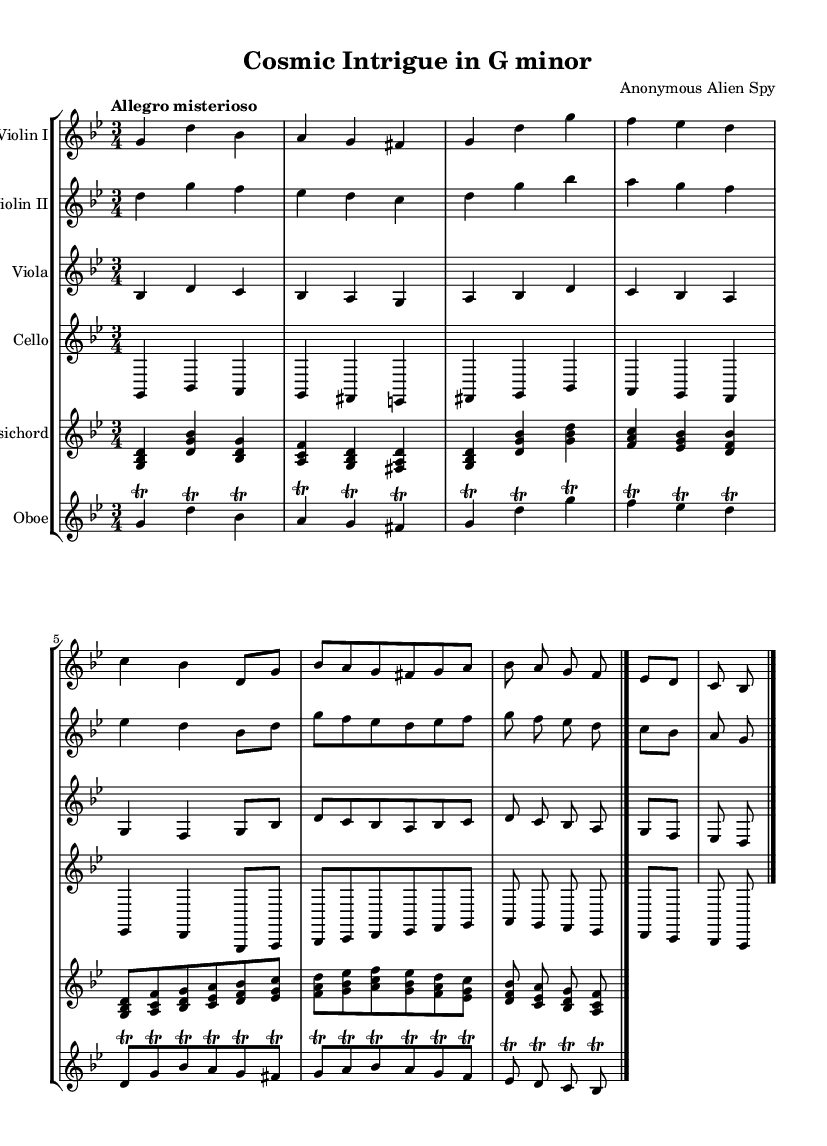What is the key signature of this music? The key signature is indicated at the beginning of the score and shows two flats, which corresponds to G minor.
Answer: G minor What is the time signature of the piece? The time signature is displayed near the beginning, and it shows three beats per measure, indicated as 3/4.
Answer: 3/4 What is the tempo marking for this piece? The tempo marking is stated at the beginning, indicating the piece should be played in a mysterious and lively manner, labeled as "Allegro misterioso."
Answer: Allegro misterioso How many instruments are used in this orchestral suite? By counting each distinct staff in the score, we find that there are six instruments: Violin I, Violin II, Viola, Cello, Harpsichord, and Oboe.
Answer: Six Which instrument plays the lowest pitch range in this suite? Looking at the staff arrangement, the Cello is the instrument that is positioned the lowest on the page, indicating it plays the lowest pitch range.
Answer: Cello What composition technique is primarily used for the Oboe part? The Oboe part features trills, which are rapid alternations between two adjacent notes, as indicated by the trill marks throughout the line.
Answer: Trills What is the final measure of this orchestral suite? The final measure is indicated by the double bar line at the end of the score, signifying the conclusion of the piece.
Answer: Double bar line 